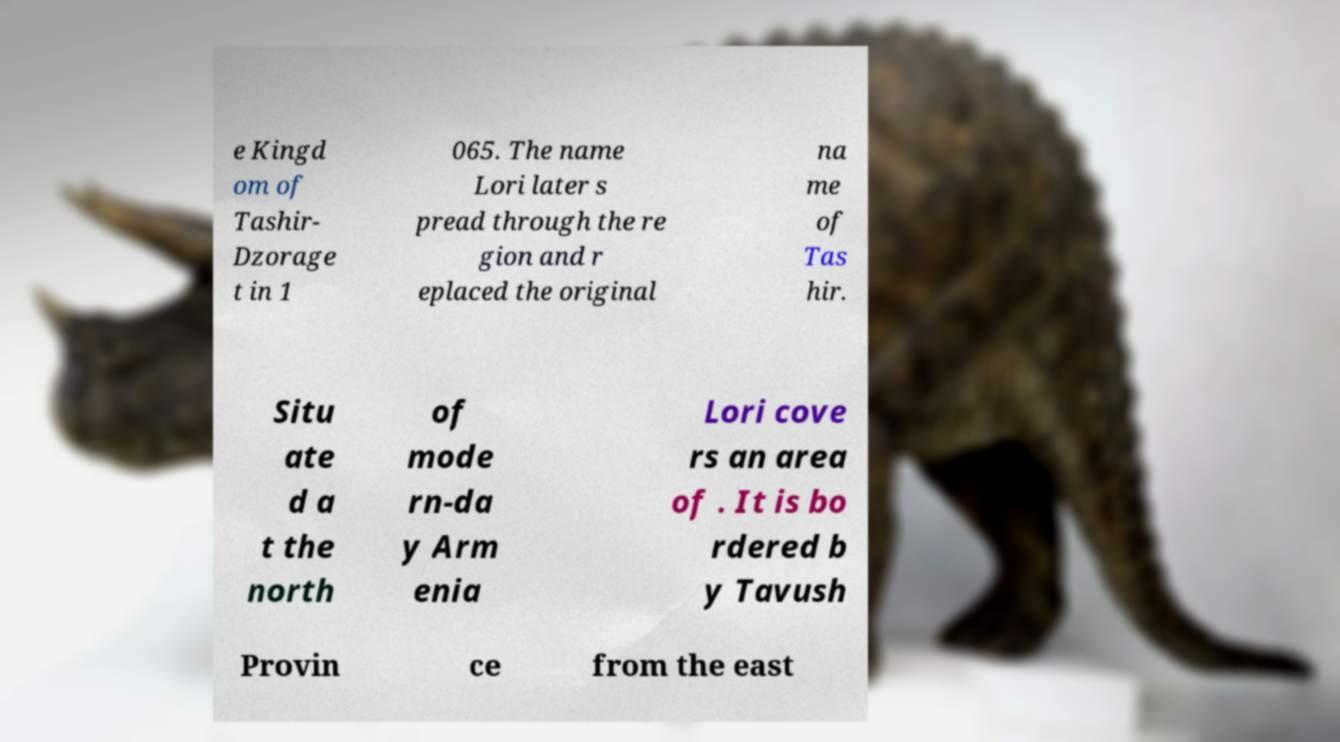Could you assist in decoding the text presented in this image and type it out clearly? e Kingd om of Tashir- Dzorage t in 1 065. The name Lori later s pread through the re gion and r eplaced the original na me of Tas hir. Situ ate d a t the north of mode rn-da y Arm enia Lori cove rs an area of . It is bo rdered b y Tavush Provin ce from the east 